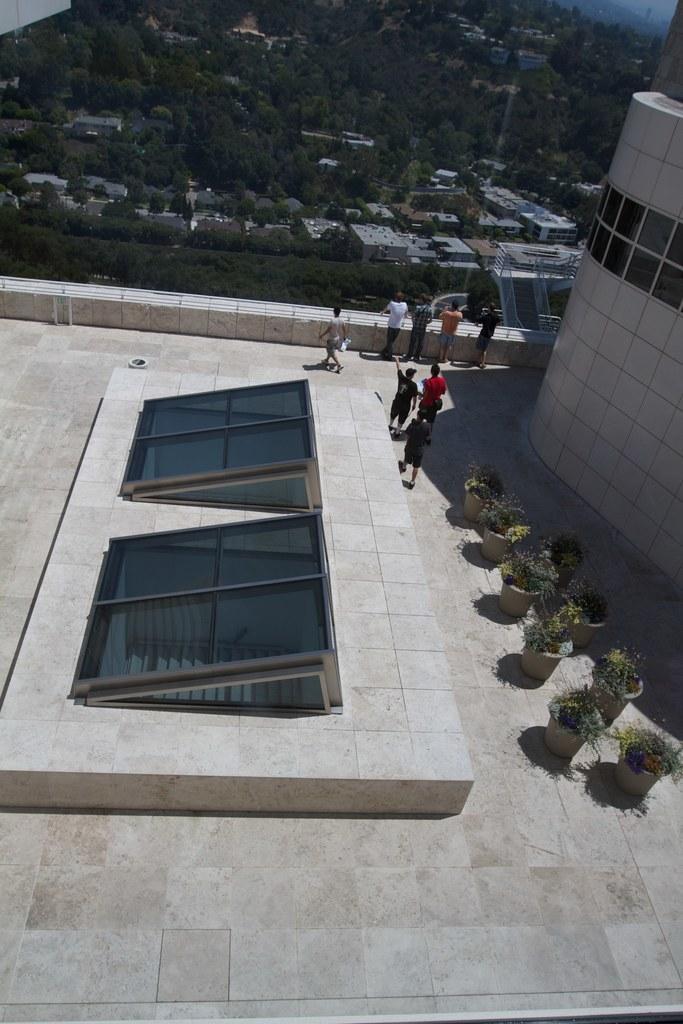Could you give a brief overview of what you see in this image? In this image I can see the terrace of the building on which I can see few glass windows, few flower pots with plants in them and few persons standing. In the background I can see few trees, few buildings and the sky. 